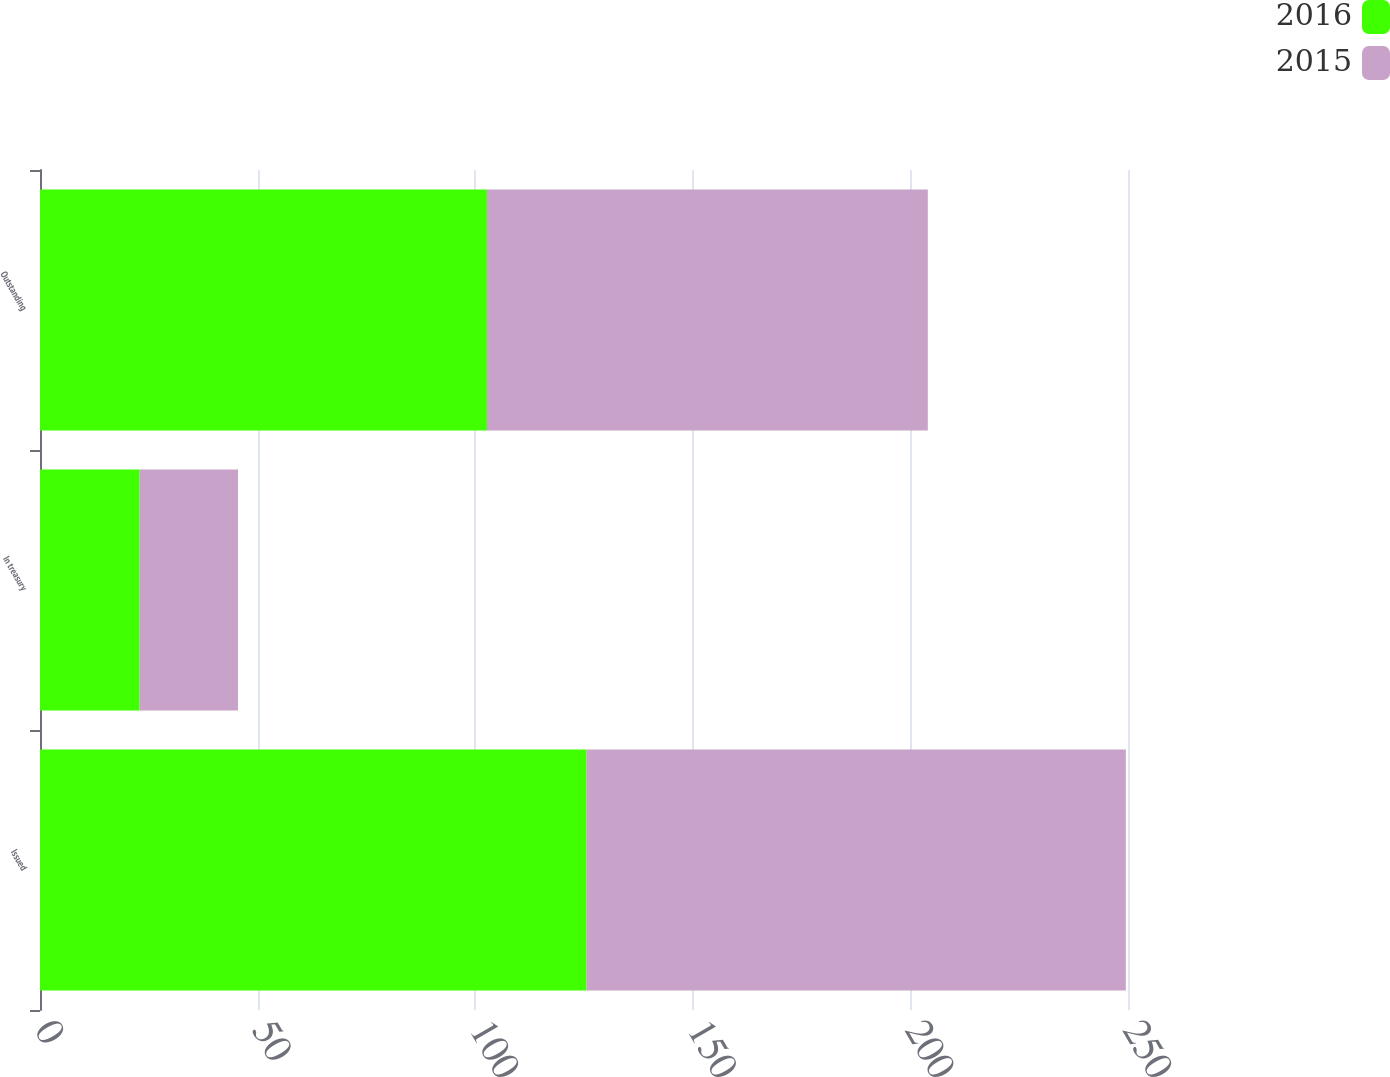Convert chart to OTSL. <chart><loc_0><loc_0><loc_500><loc_500><stacked_bar_chart><ecel><fcel>Issued<fcel>In treasury<fcel>Outstanding<nl><fcel>2016<fcel>125.6<fcel>22.9<fcel>102.7<nl><fcel>2015<fcel>123.9<fcel>22.6<fcel>101.3<nl></chart> 